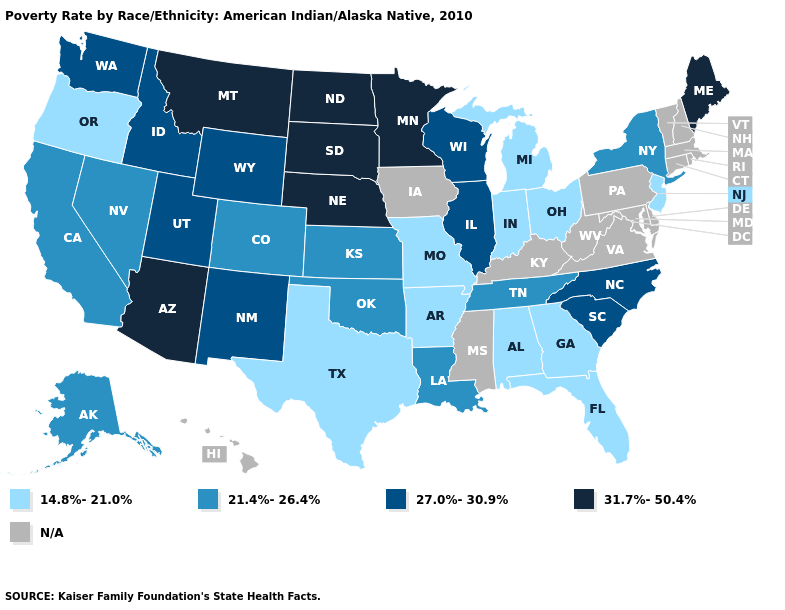What is the value of Hawaii?
Be succinct. N/A. Name the states that have a value in the range N/A?
Be succinct. Connecticut, Delaware, Hawaii, Iowa, Kentucky, Maryland, Massachusetts, Mississippi, New Hampshire, Pennsylvania, Rhode Island, Vermont, Virginia, West Virginia. Among the states that border Pennsylvania , which have the lowest value?
Short answer required. New Jersey, Ohio. What is the highest value in the USA?
Give a very brief answer. 31.7%-50.4%. Which states have the highest value in the USA?
Give a very brief answer. Arizona, Maine, Minnesota, Montana, Nebraska, North Dakota, South Dakota. Name the states that have a value in the range 27.0%-30.9%?
Quick response, please. Idaho, Illinois, New Mexico, North Carolina, South Carolina, Utah, Washington, Wisconsin, Wyoming. What is the value of Wyoming?
Concise answer only. 27.0%-30.9%. What is the value of Tennessee?
Write a very short answer. 21.4%-26.4%. Does Louisiana have the lowest value in the South?
Be succinct. No. Which states have the lowest value in the USA?
Write a very short answer. Alabama, Arkansas, Florida, Georgia, Indiana, Michigan, Missouri, New Jersey, Ohio, Oregon, Texas. Does New York have the lowest value in the Northeast?
Short answer required. No. Does Louisiana have the lowest value in the USA?
Answer briefly. No. Is the legend a continuous bar?
Give a very brief answer. No. 